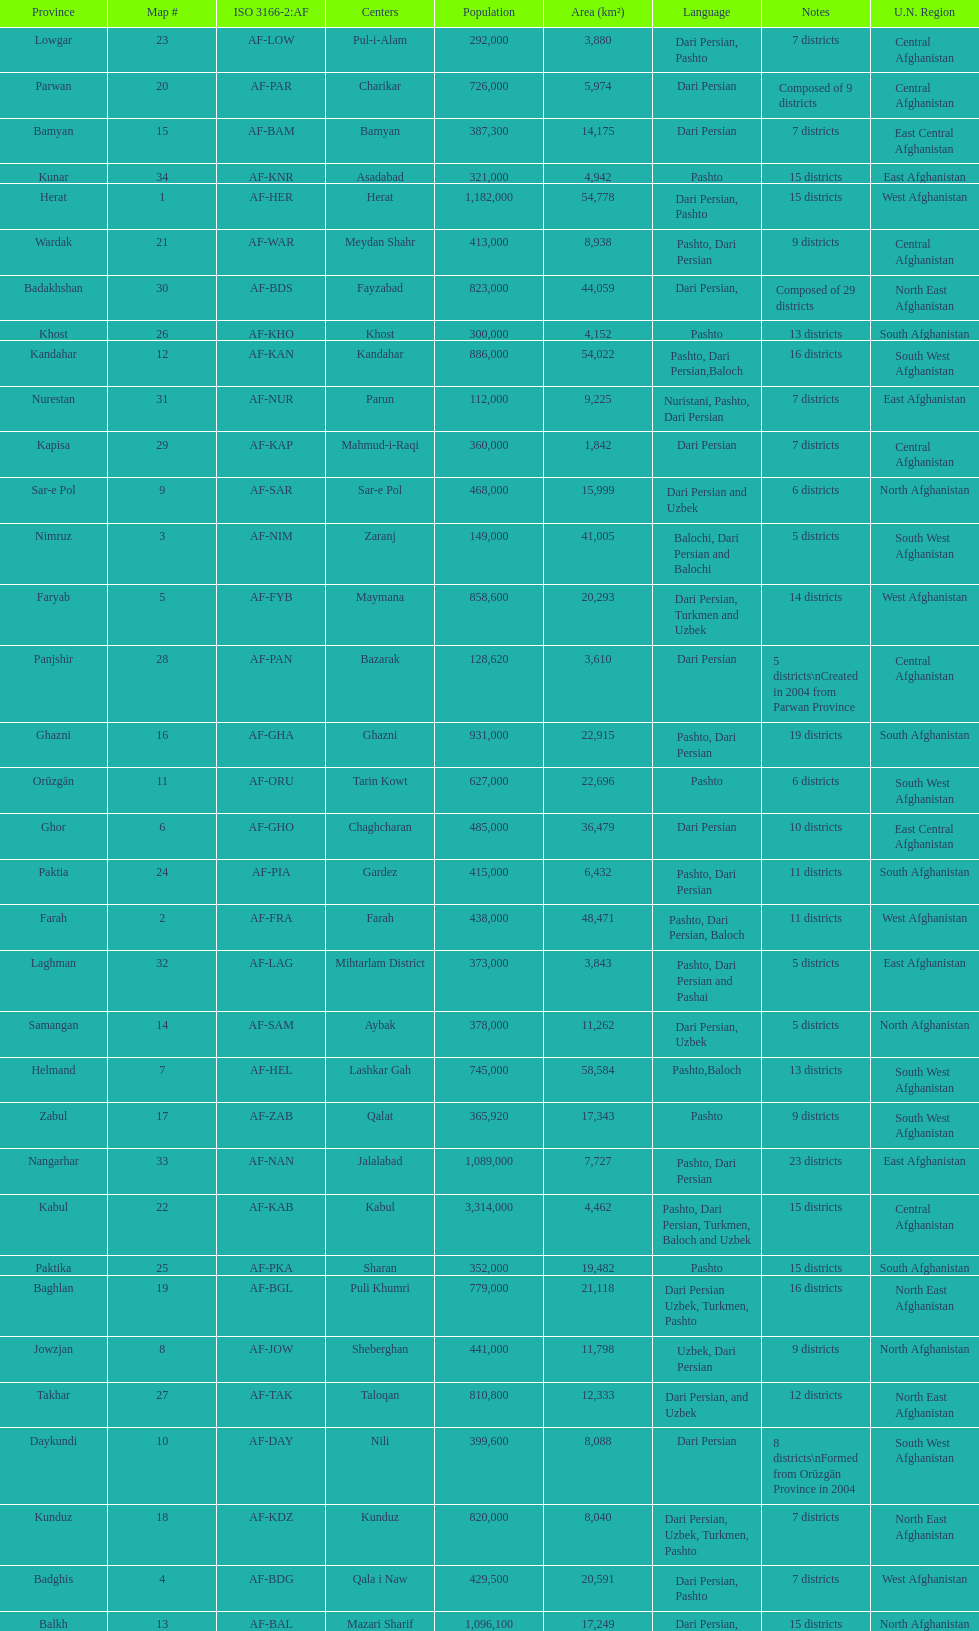Give the province with the least population Nurestan. 